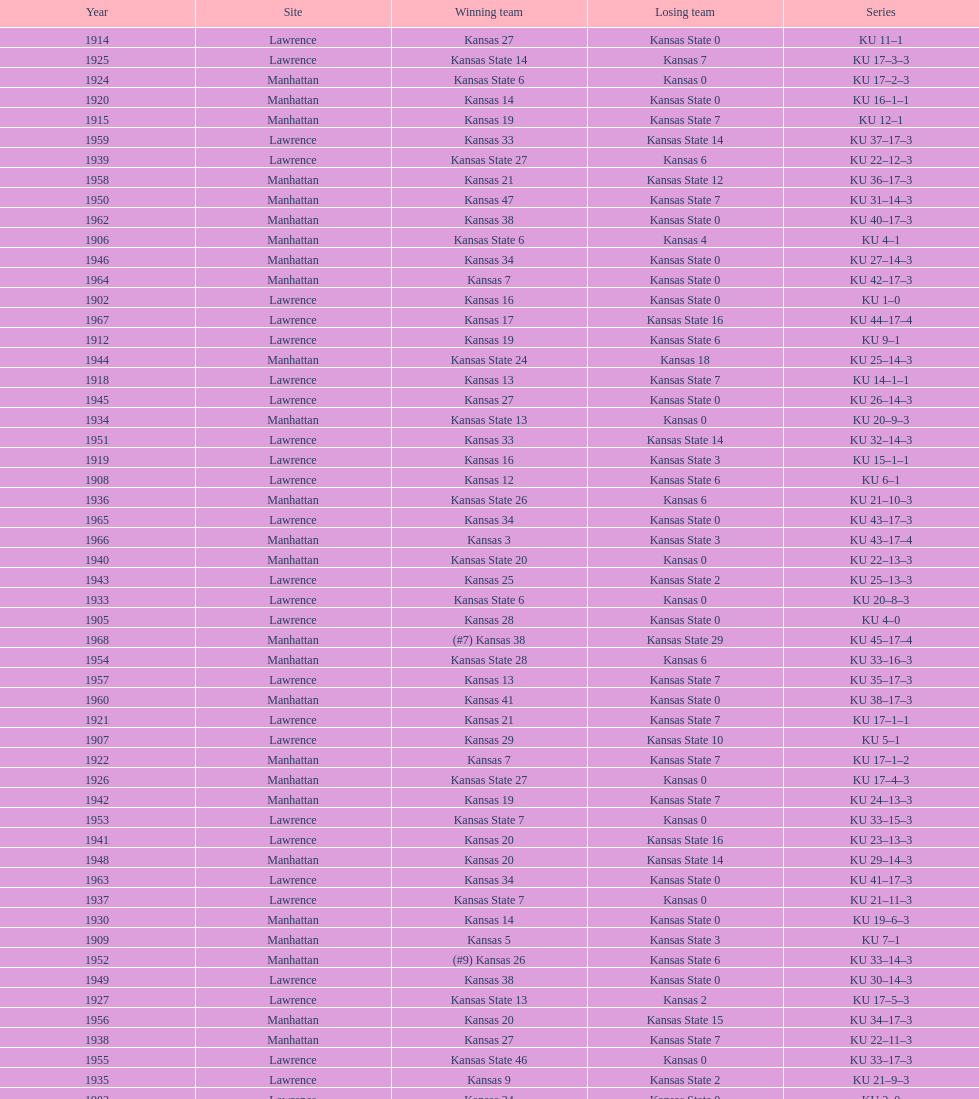Who had the most wins in the 1950's: kansas or kansas state? Kansas. 